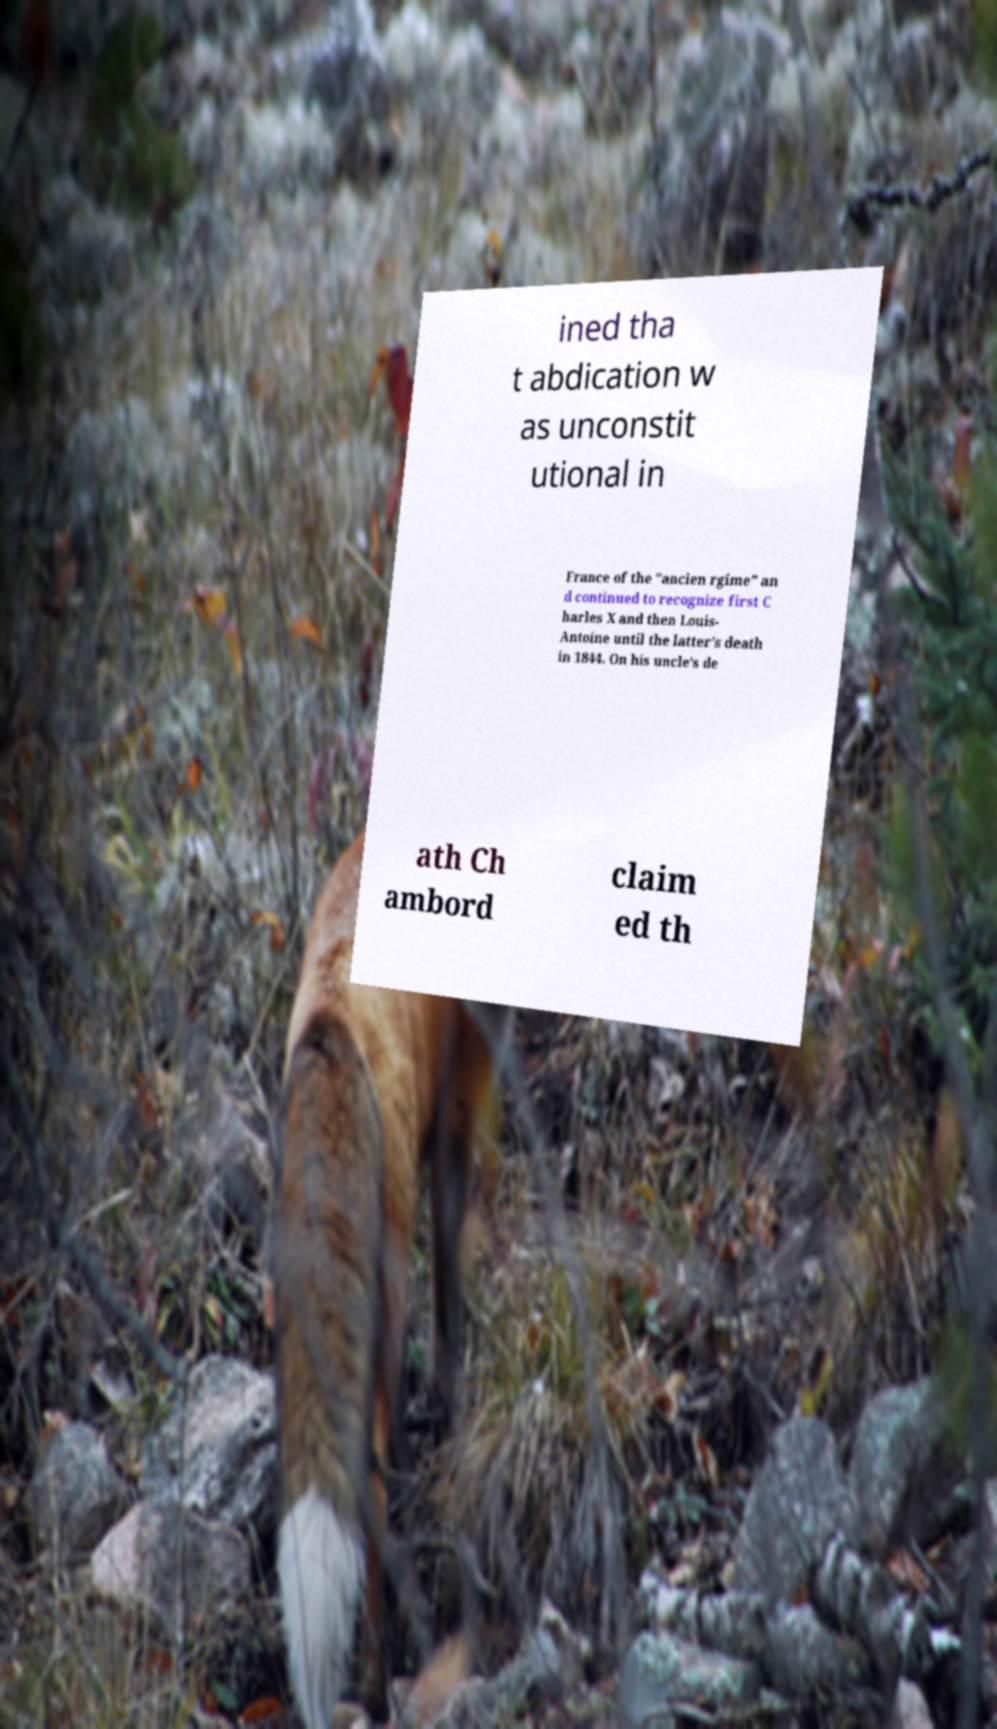There's text embedded in this image that I need extracted. Can you transcribe it verbatim? ined tha t abdication w as unconstit utional in France of the "ancien rgime" an d continued to recognize first C harles X and then Louis- Antoine until the latter's death in 1844. On his uncle's de ath Ch ambord claim ed th 